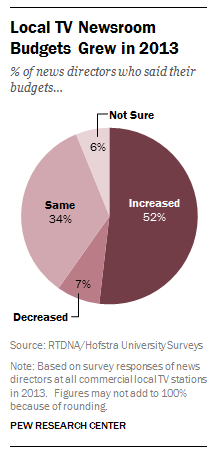Give some essential details in this illustration. Out of the segments that display less than 52%, only 3 of them have shown. The segment with a value of 52% in the pie graph represents an increase. 